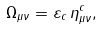<formula> <loc_0><loc_0><loc_500><loc_500>\Omega _ { \mu \nu } = \varepsilon _ { c } \, \eta ^ { c } _ { \mu \nu } ,</formula> 